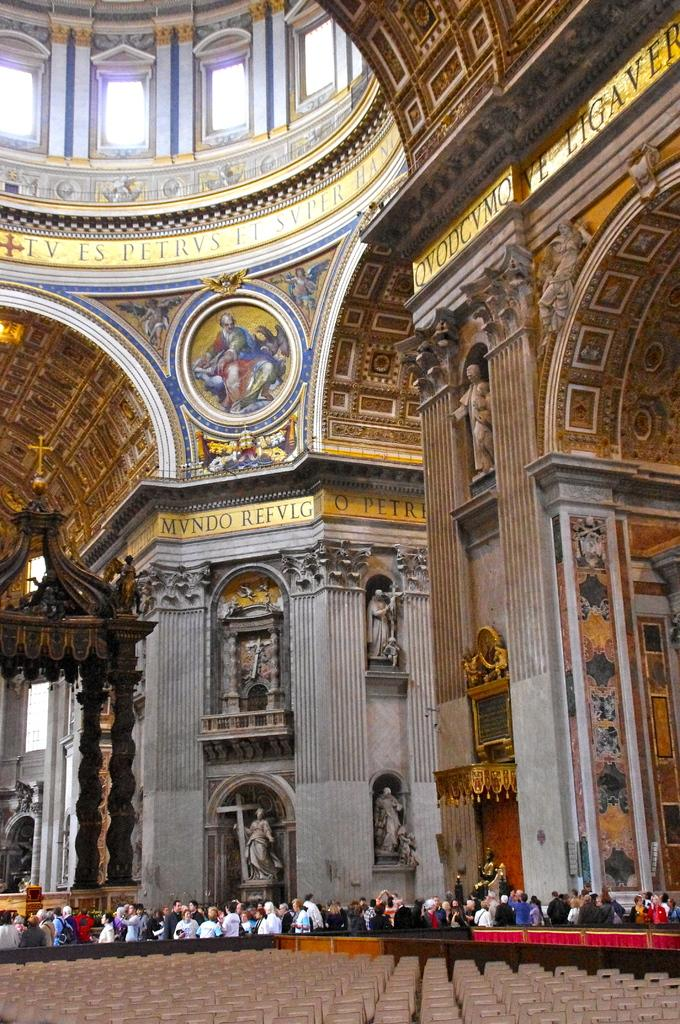What type of furniture can be seen in the image? There are chairs in the image. Who or what is present in the image? There are people in the image. What type of location is visible in the image? The interior of a building is visible in the image. What is the color and design of the ceiling in the image? The ceiling is gold, yellow, and white in color. What architectural feature allows natural light to enter the room? There are windows in the image. What type of paste is being used to decorate the walls in the image? There is no mention of paste or wall decoration in the image; it primarily features chairs, people, and a building interior. 